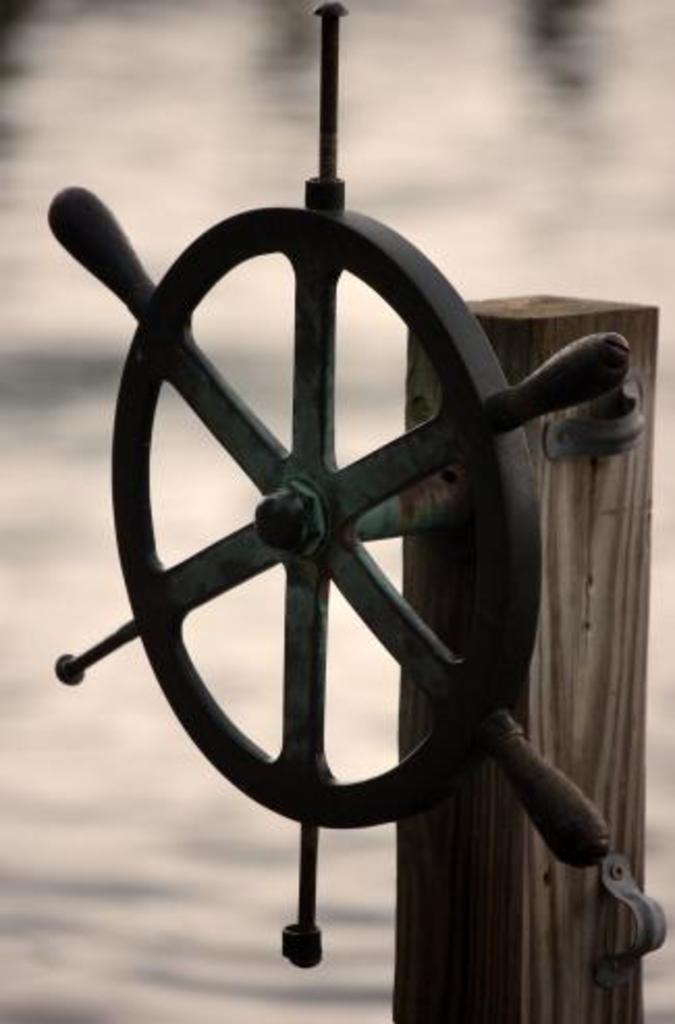In one or two sentences, can you explain what this image depicts? In this picture we can observe a black color steering wheel fixed to the wooden pole. In the background we can observe water. 